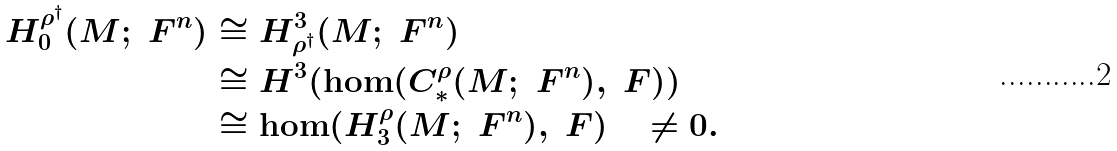Convert formula to latex. <formula><loc_0><loc_0><loc_500><loc_500>H _ { 0 } ^ { \rho ^ { \dagger } } ( M ; \ F ^ { n } ) & \cong H _ { \rho ^ { \dagger } } ^ { 3 } ( M ; \ F ^ { n } ) \\ & \cong H ^ { 3 } ( \hom ( C _ { * } ^ { \rho } ( M ; \ F ^ { n } ) , \ F ) ) \\ & \cong \hom ( H _ { 3 } ^ { \rho } ( M ; \ F ^ { n } ) , \ F ) \quad \neq 0 .</formula> 